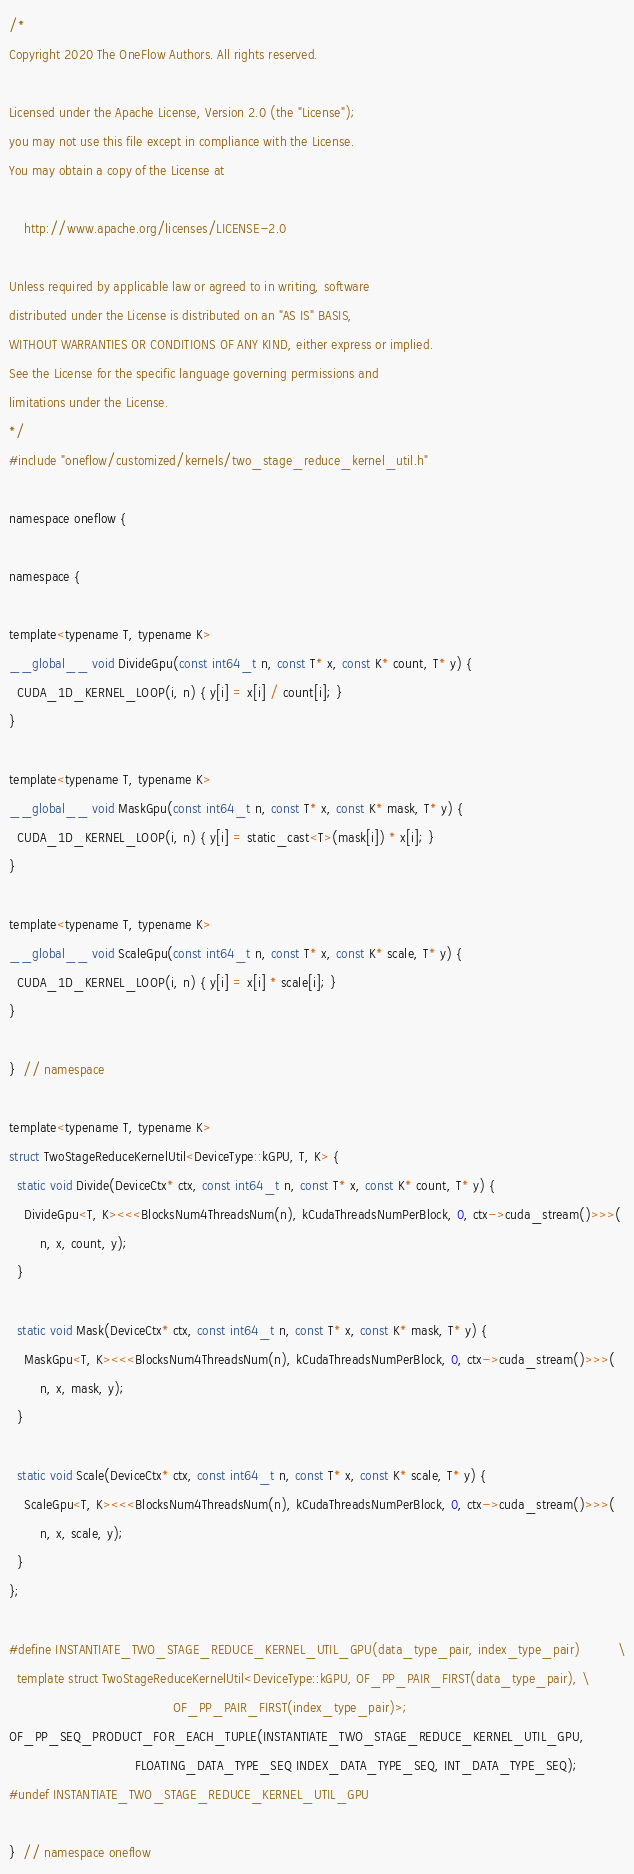<code> <loc_0><loc_0><loc_500><loc_500><_Cuda_>/*
Copyright 2020 The OneFlow Authors. All rights reserved.

Licensed under the Apache License, Version 2.0 (the "License");
you may not use this file except in compliance with the License.
You may obtain a copy of the License at

    http://www.apache.org/licenses/LICENSE-2.0

Unless required by applicable law or agreed to in writing, software
distributed under the License is distributed on an "AS IS" BASIS,
WITHOUT WARRANTIES OR CONDITIONS OF ANY KIND, either express or implied.
See the License for the specific language governing permissions and
limitations under the License.
*/
#include "oneflow/customized/kernels/two_stage_reduce_kernel_util.h"

namespace oneflow {

namespace {

template<typename T, typename K>
__global__ void DivideGpu(const int64_t n, const T* x, const K* count, T* y) {
  CUDA_1D_KERNEL_LOOP(i, n) { y[i] = x[i] / count[i]; }
}

template<typename T, typename K>
__global__ void MaskGpu(const int64_t n, const T* x, const K* mask, T* y) {
  CUDA_1D_KERNEL_LOOP(i, n) { y[i] = static_cast<T>(mask[i]) * x[i]; }
}

template<typename T, typename K>
__global__ void ScaleGpu(const int64_t n, const T* x, const K* scale, T* y) {
  CUDA_1D_KERNEL_LOOP(i, n) { y[i] = x[i] * scale[i]; }
}

}  // namespace

template<typename T, typename K>
struct TwoStageReduceKernelUtil<DeviceType::kGPU, T, K> {
  static void Divide(DeviceCtx* ctx, const int64_t n, const T* x, const K* count, T* y) {
    DivideGpu<T, K><<<BlocksNum4ThreadsNum(n), kCudaThreadsNumPerBlock, 0, ctx->cuda_stream()>>>(
        n, x, count, y);
  }

  static void Mask(DeviceCtx* ctx, const int64_t n, const T* x, const K* mask, T* y) {
    MaskGpu<T, K><<<BlocksNum4ThreadsNum(n), kCudaThreadsNumPerBlock, 0, ctx->cuda_stream()>>>(
        n, x, mask, y);
  }

  static void Scale(DeviceCtx* ctx, const int64_t n, const T* x, const K* scale, T* y) {
    ScaleGpu<T, K><<<BlocksNum4ThreadsNum(n), kCudaThreadsNumPerBlock, 0, ctx->cuda_stream()>>>(
        n, x, scale, y);
  }
};

#define INSTANTIATE_TWO_STAGE_REDUCE_KERNEL_UTIL_GPU(data_type_pair, index_type_pair)          \
  template struct TwoStageReduceKernelUtil<DeviceType::kGPU, OF_PP_PAIR_FIRST(data_type_pair), \
                                           OF_PP_PAIR_FIRST(index_type_pair)>;
OF_PP_SEQ_PRODUCT_FOR_EACH_TUPLE(INSTANTIATE_TWO_STAGE_REDUCE_KERNEL_UTIL_GPU,
                                 FLOATING_DATA_TYPE_SEQ INDEX_DATA_TYPE_SEQ, INT_DATA_TYPE_SEQ);
#undef INSTANTIATE_TWO_STAGE_REDUCE_KERNEL_UTIL_GPU

}  // namespace oneflow
</code> 